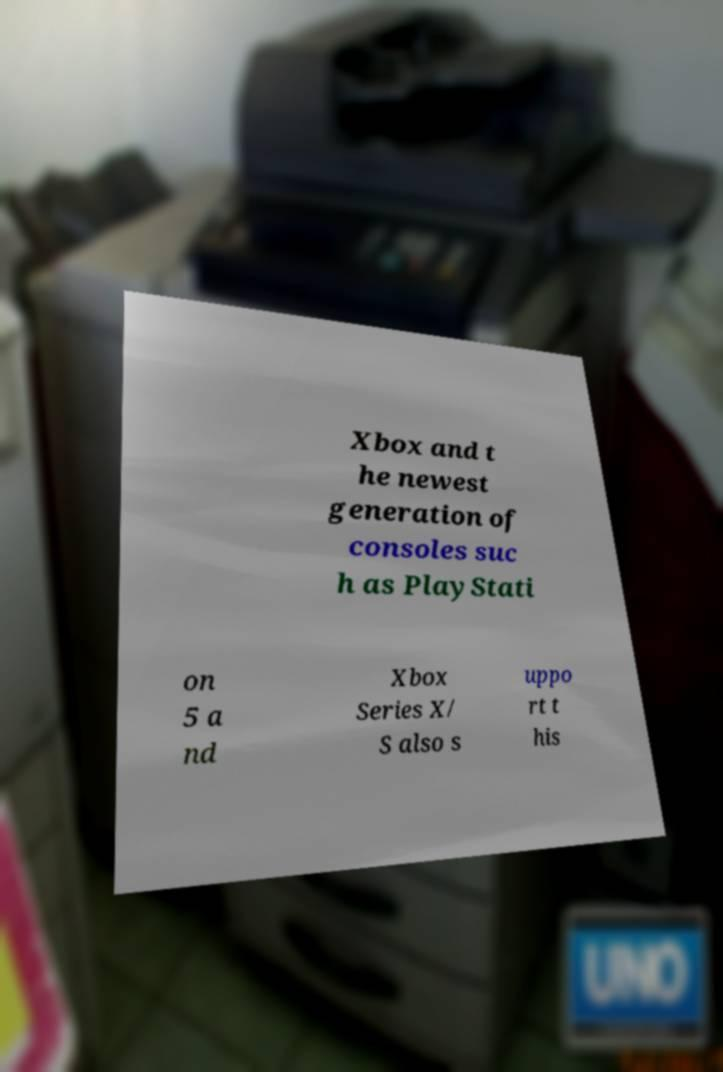Can you read and provide the text displayed in the image?This photo seems to have some interesting text. Can you extract and type it out for me? Xbox and t he newest generation of consoles suc h as PlayStati on 5 a nd Xbox Series X/ S also s uppo rt t his 